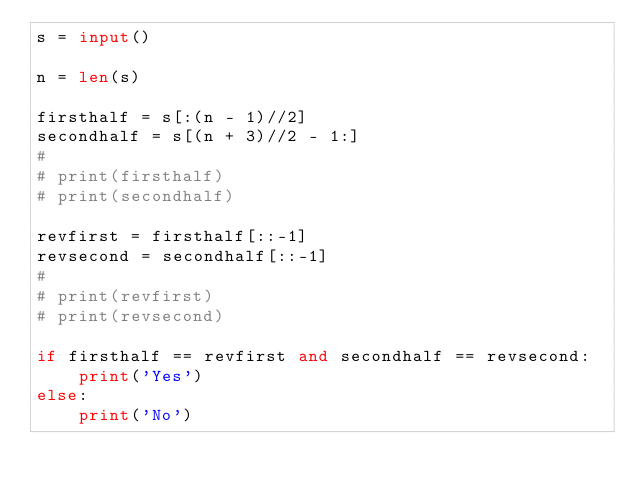Convert code to text. <code><loc_0><loc_0><loc_500><loc_500><_Python_>s = input()

n = len(s)

firsthalf = s[:(n - 1)//2]
secondhalf = s[(n + 3)//2 - 1:]
#
# print(firsthalf)
# print(secondhalf)

revfirst = firsthalf[::-1]
revsecond = secondhalf[::-1]
#
# print(revfirst)
# print(revsecond)

if firsthalf == revfirst and secondhalf == revsecond:
    print('Yes')
else:
    print('No')</code> 